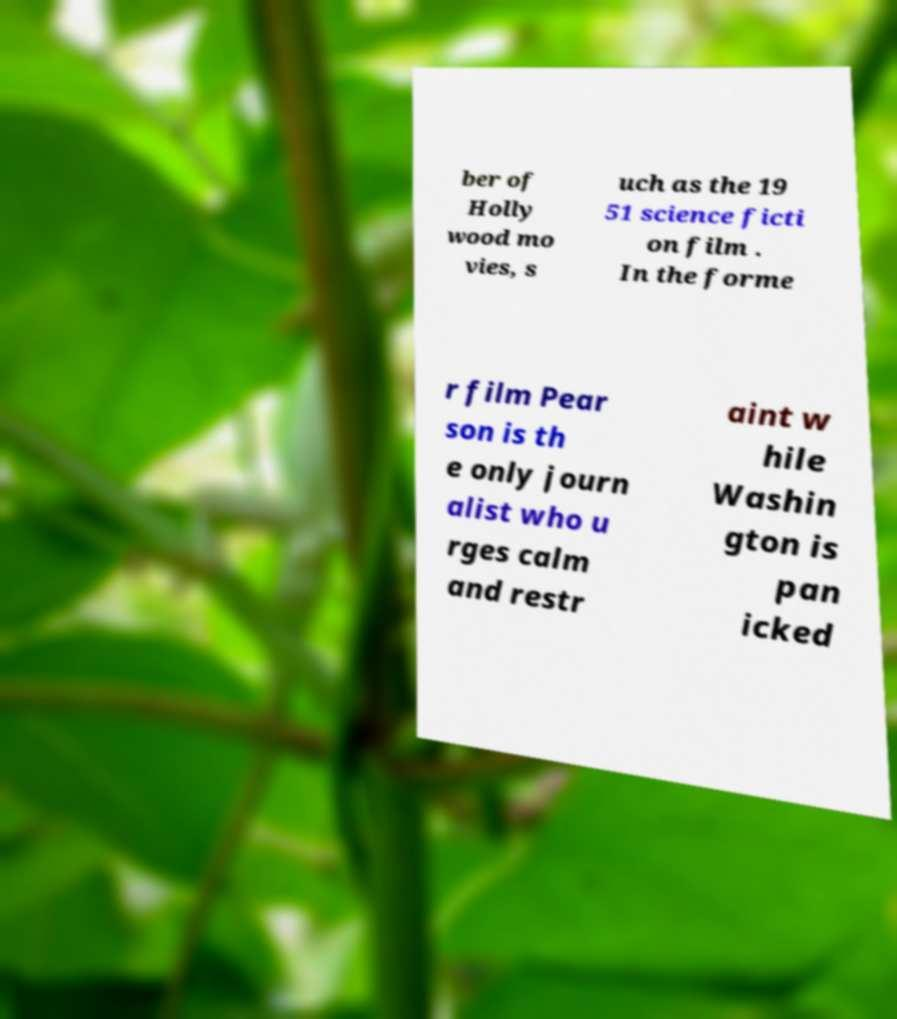What messages or text are displayed in this image? I need them in a readable, typed format. ber of Holly wood mo vies, s uch as the 19 51 science ficti on film . In the forme r film Pear son is th e only journ alist who u rges calm and restr aint w hile Washin gton is pan icked 